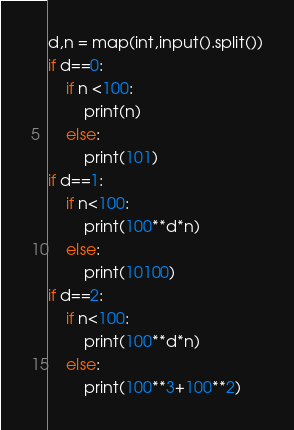Convert code to text. <code><loc_0><loc_0><loc_500><loc_500><_Python_>d,n = map(int,input().split())
if d==0:
    if n <100:
        print(n)
    else:
        print(101)
if d==1:
    if n<100:
        print(100**d*n)
    else:
        print(10100)
if d==2:
    if n<100:
        print(100**d*n)
    else:
        print(100**3+100**2)</code> 